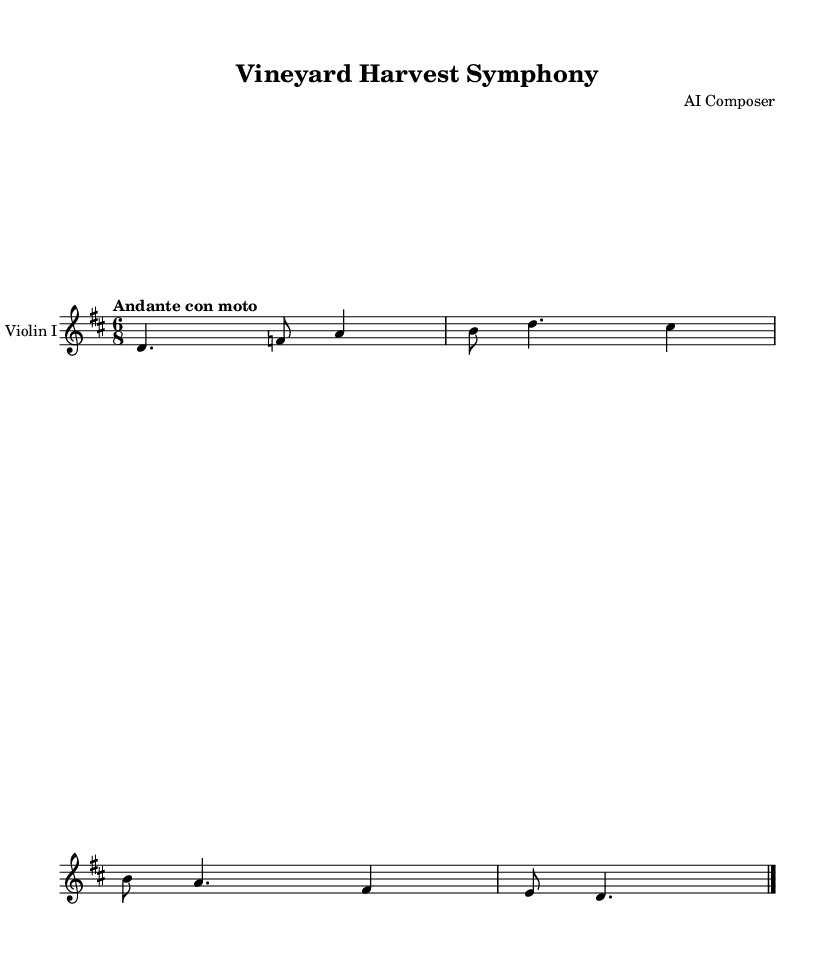What is the key signature of this music? The key signature is D major, which has two sharps (F# and C#). This can be identified at the beginning of the staff, where the signature is indicated before the notes.
Answer: D major What is the time signature of this music? The time signature is 6/8, which indicates that there are six eighth notes per measure. This can be found at the beginning of the piece next to the key signature.
Answer: 6/8 What is the tempo marking for this music? The tempo marking is "Andante con moto," which suggests a moderately slow pace with some movement. This is indicated in the tempo directive located near the start of the first staff.
Answer: Andante con moto How many measures are in the provided excerpt? There is a total of two measures in the excerpt, which can be counted by observing the bar lines that separate them. Each section between bar lines represents one measure.
Answer: 2 What note is the first note in the melody? The first note in the melody is D. This can be found by looking at the very first note on the staff.
Answer: D What rhythmic pattern does the melody predominantly follow? The melody predominantly follows a dotted quarter note and eighth note pattern, which is a common rhythm in 6/8 time. This pattern is observed in the way the notes are grouped and spaced within the measures.
Answer: Dotted quarter and eighth 